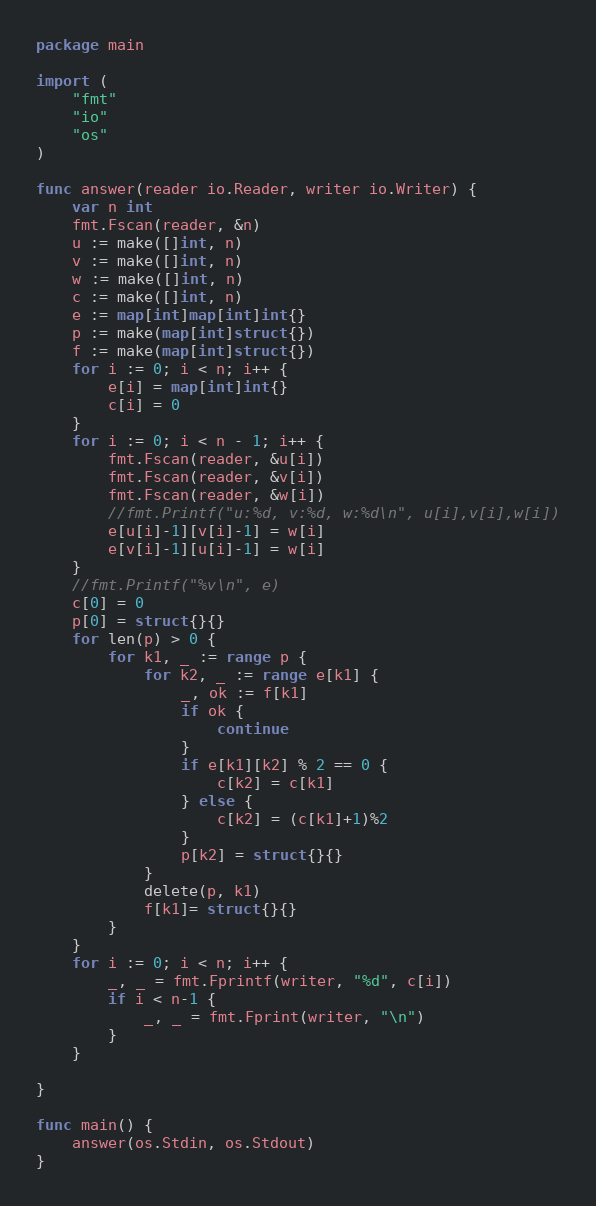<code> <loc_0><loc_0><loc_500><loc_500><_Go_>package main

import (
	"fmt"
	"io"
	"os"
)

func answer(reader io.Reader, writer io.Writer) {
	var n int
	fmt.Fscan(reader, &n)
	u := make([]int, n)
	v := make([]int, n)
	w := make([]int, n)
	c := make([]int, n)
	e := map[int]map[int]int{}
	p := make(map[int]struct{})
	f := make(map[int]struct{})
	for i := 0; i < n; i++ {
		e[i] = map[int]int{}
		c[i] = 0
	}
	for i := 0; i < n - 1; i++ {
		fmt.Fscan(reader, &u[i])
		fmt.Fscan(reader, &v[i])
		fmt.Fscan(reader, &w[i])
		//fmt.Printf("u:%d, v:%d, w:%d\n", u[i],v[i],w[i])
		e[u[i]-1][v[i]-1] = w[i]
		e[v[i]-1][u[i]-1] = w[i]
	}
	//fmt.Printf("%v\n", e)
	c[0] = 0
	p[0] = struct{}{}
	for len(p) > 0 {
		for k1, _ := range p {
			for k2, _ := range e[k1] {
				_, ok := f[k1]
				if ok {
					continue
				}
				if e[k1][k2] % 2 == 0 {
					c[k2] = c[k1]
				} else {
					c[k2] = (c[k1]+1)%2
				}
				p[k2] = struct{}{}
			}
			delete(p, k1)
			f[k1]= struct{}{}
		}
	}
	for i := 0; i < n; i++ {
		_, _ = fmt.Fprintf(writer, "%d", c[i])
		if i < n-1 {
			_, _ = fmt.Fprint(writer, "\n")
		}
	}

}

func main() {
	answer(os.Stdin, os.Stdout)
}
</code> 